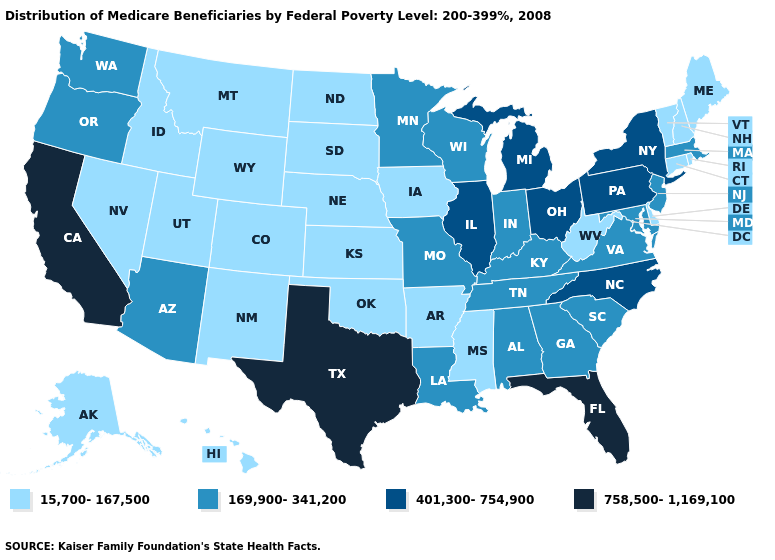Name the states that have a value in the range 169,900-341,200?
Give a very brief answer. Alabama, Arizona, Georgia, Indiana, Kentucky, Louisiana, Maryland, Massachusetts, Minnesota, Missouri, New Jersey, Oregon, South Carolina, Tennessee, Virginia, Washington, Wisconsin. Name the states that have a value in the range 758,500-1,169,100?
Keep it brief. California, Florida, Texas. What is the value of Missouri?
Keep it brief. 169,900-341,200. Does Oregon have the lowest value in the West?
Be succinct. No. Does the map have missing data?
Answer briefly. No. Which states hav the highest value in the West?
Keep it brief. California. Is the legend a continuous bar?
Keep it brief. No. What is the highest value in the USA?
Give a very brief answer. 758,500-1,169,100. What is the value of Arizona?
Be succinct. 169,900-341,200. What is the highest value in states that border Mississippi?
Be succinct. 169,900-341,200. What is the lowest value in the South?
Keep it brief. 15,700-167,500. Name the states that have a value in the range 401,300-754,900?
Keep it brief. Illinois, Michigan, New York, North Carolina, Ohio, Pennsylvania. Does Oregon have a higher value than Virginia?
Keep it brief. No. What is the value of Hawaii?
Quick response, please. 15,700-167,500. 